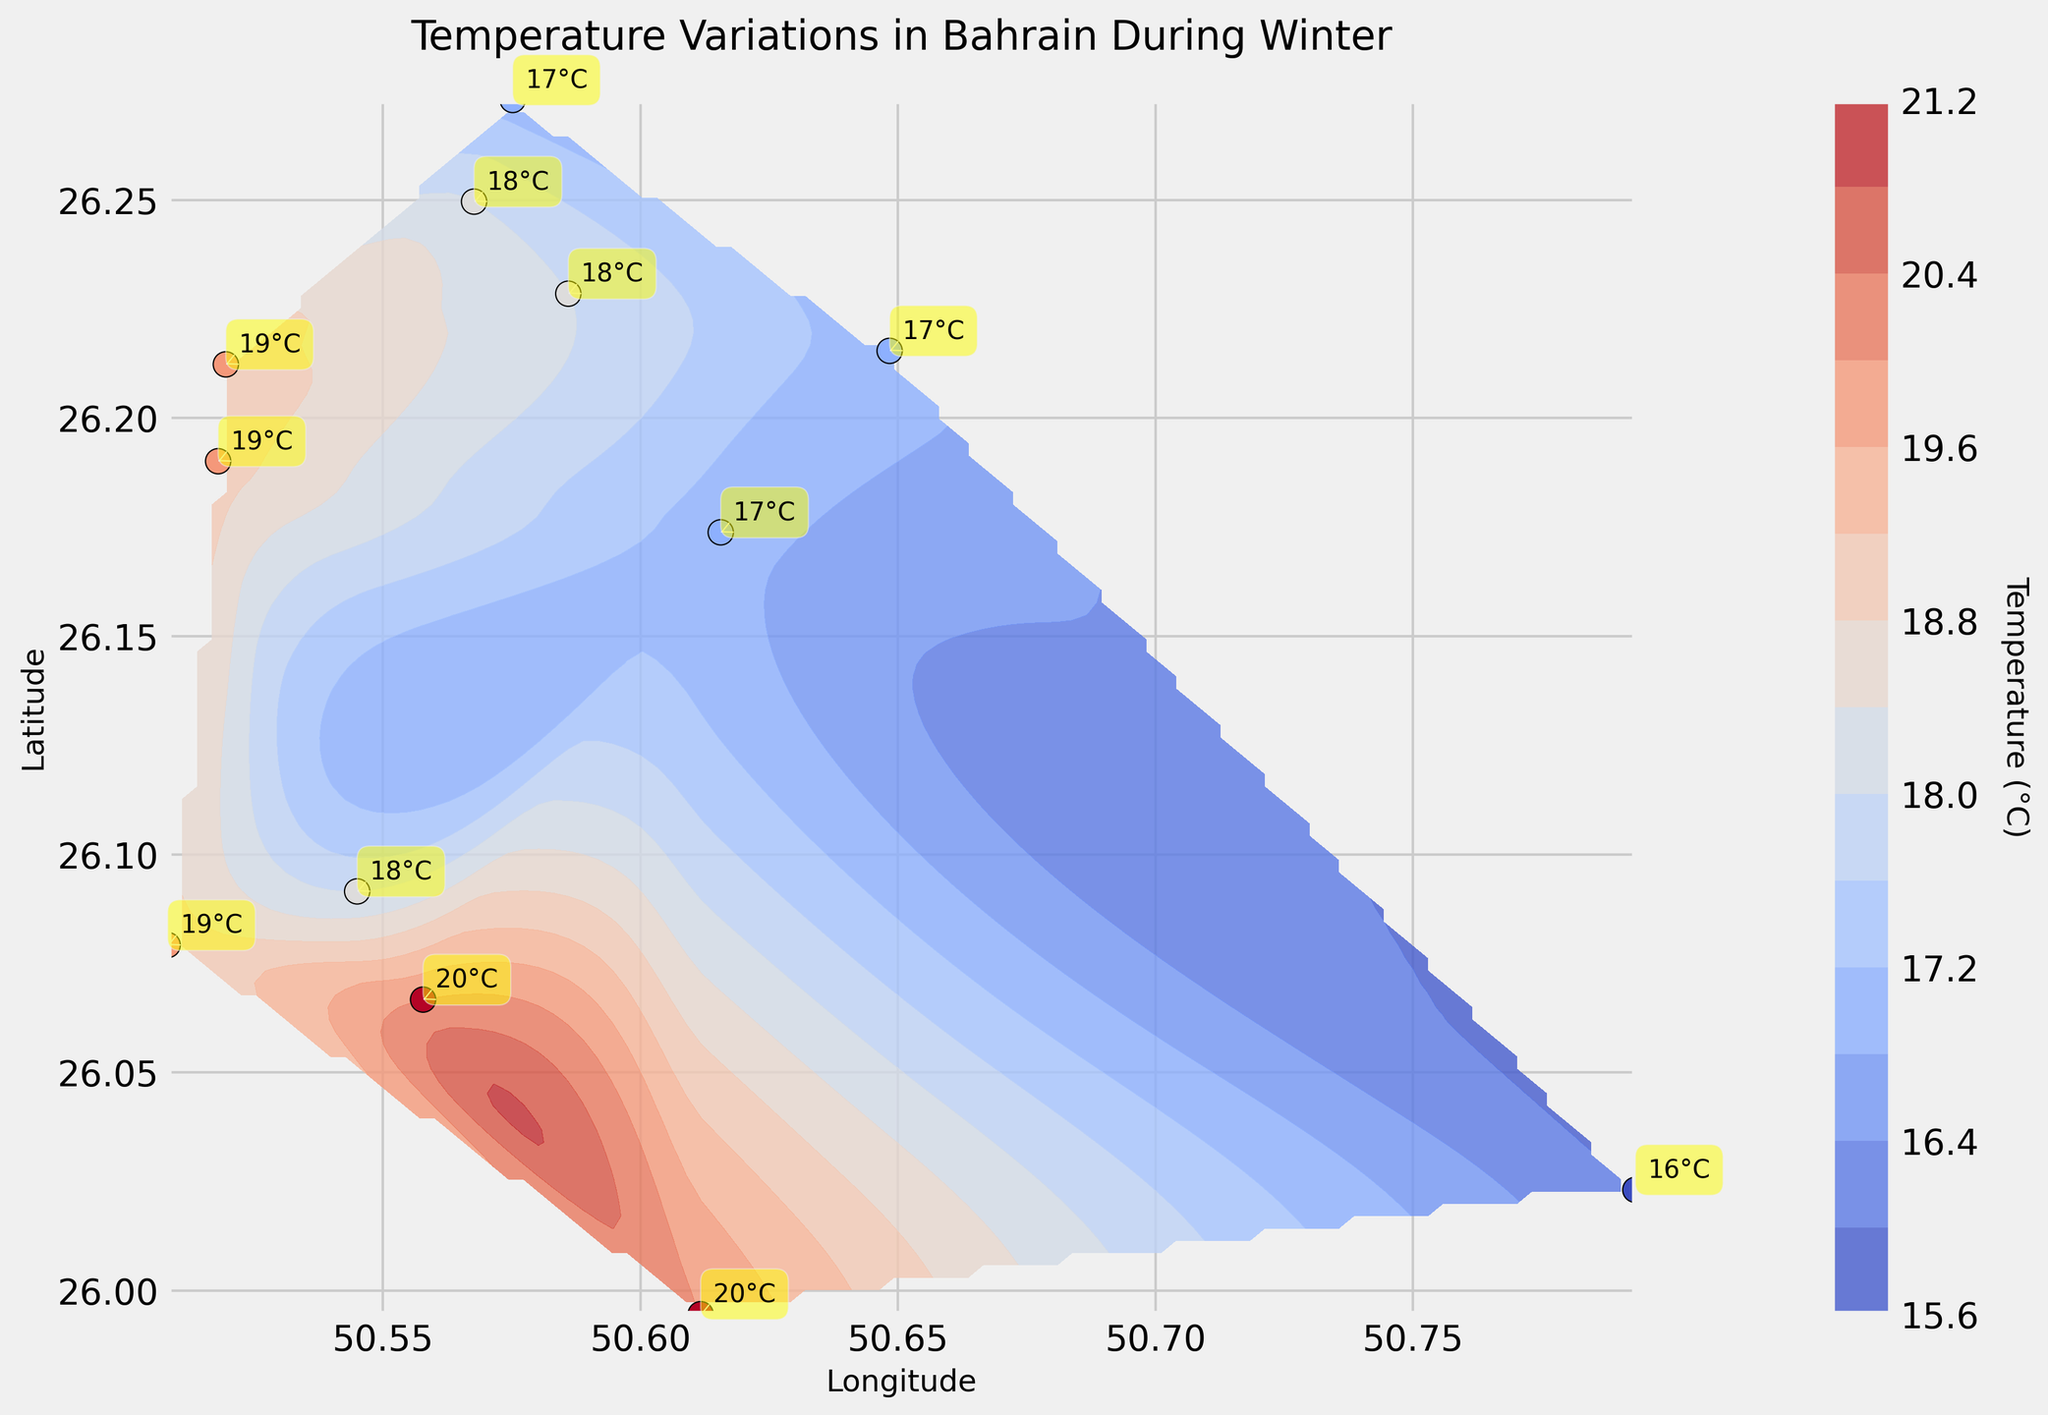What is the temperature recorded at the southernmost location? The southernmost location on the plot can be determined by finding the point with the lowest latitude. Checking the plot, the southernmost point is around latitude 25.9946 with a temperature labeled as 20°C.
Answer: 20°C How many data points have a temperature of 18°C? Look for the labels on the plot that show 18°C. The plot shows 18°C at three locations.
Answer: 3 Is there a place on the plot where the temperature is below 17°C? Check all the labeled temperature values on the plot to see if there is any temperature below 17°C. The lowest recorded temperature is 16°C.
Answer: Yes Which two locations have the same highest recorded temperature? Identify the highest temperature on the plot and find which locations share this value. The highest temperature shown is 20°C at 25.9946, 50.6117 and 26.0667, 50.5578.
Answer: 25.9946, 50.6117 and 26.0667, 50.5578 What is the temperature difference between the westernmost and easternmost locations? Determine the westernmost (lowest longitude) and easternmost (highest longitude) locations and their temperatures. The westernmost location is 49.5195 with 19°C, and the easternmost is 50.7932 with 16°C. The difference is 19°C - 16°C = 3°C.
Answer: 3°C Which region has the warmest average temperature, the north or the south? Divide the plot into northern and southern regions and calculate the average temperatures. The north (above 26.15 latitude) includes temperatures of 18, 17, 19, 18, and 18°C. The south (below 26.15 latitude) includes temperatures of 20, 16, 18, 19, 20, and 19°C. Average northern temperature = (18+17+19+18+18)/5 = 18°C; average southern temperature = (20+16+18+19+20+19)/6 ≈ 18.67°C.
Answer: The south At which coordinates is the lowest temperature recorded? Find the location with the lowest temperature value on the plot. The lowest temperature recorded is 16°C at coordinates 26.0231, 50.7932.
Answer: 26.0231, 50.7932 How does the temperature trend change from west to east across Bahrain? To understand the temperature trend from west to east, analyze the temperature changes as longitude values increase. The general trend shows a slight decrease in temperature from west to east.
Answer: Slight decrease What is the temperature gradient in the northern part of Bahrain? Observe the contour lines in the northern part, which can be calculated from temperature differences over a specific distance; steeper lines indicate a higher gradient. The northern part has relatively gentle gradients, indicating a softer temperature change.
Answer: Gentle gradient Are there more areas in Bahrain with temperatures above or below 18°C? Count the number of points indicating temperatures above 18°C and those below it. Above 18°C: 4 points (19, 20, 20, 19). Below 18°C: 6 points (18, 17, 16, 17, 17, 18).
Answer: Below 18°C 